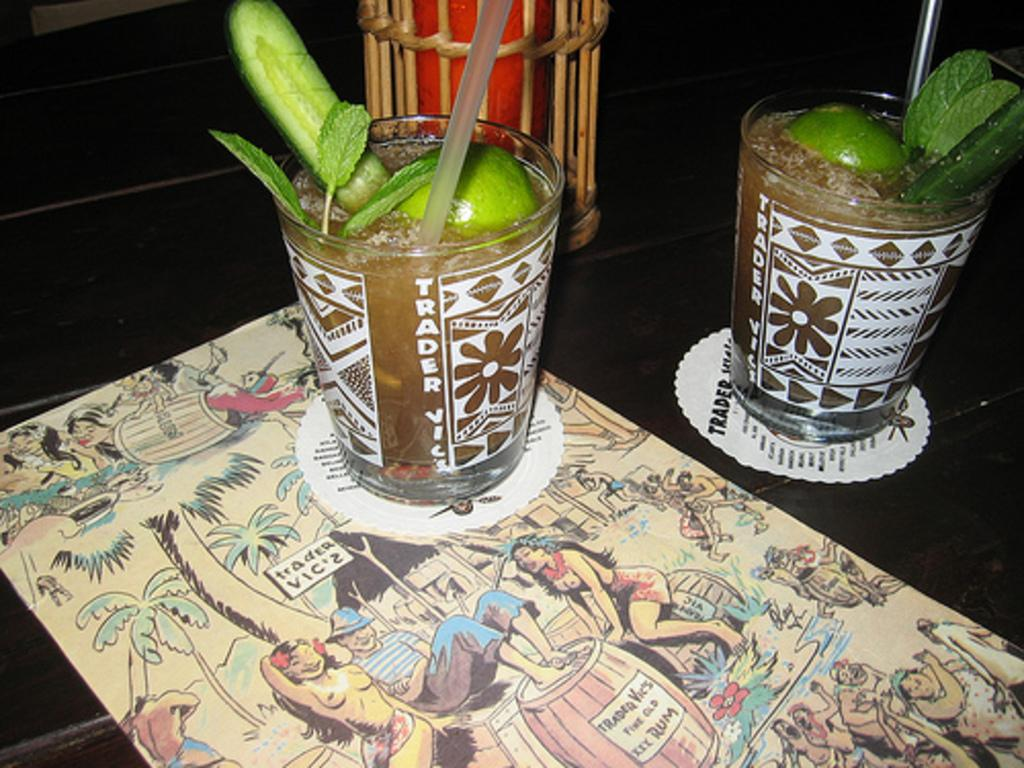What is present on the table in the image? There is a poster and glasses on the table in the image. What is inside the glasses on the table? The glasses contain lemons and straws. What is the purpose of the straws in the glasses? The straws are likely for drinking or mixing the contents of the glasses. What type of quartz can be seen in the image? There is no quartz present in the image. What process is being carried out in the image? The image does not depict a process; it shows a table with a poster and glasses containing lemons and straws. 